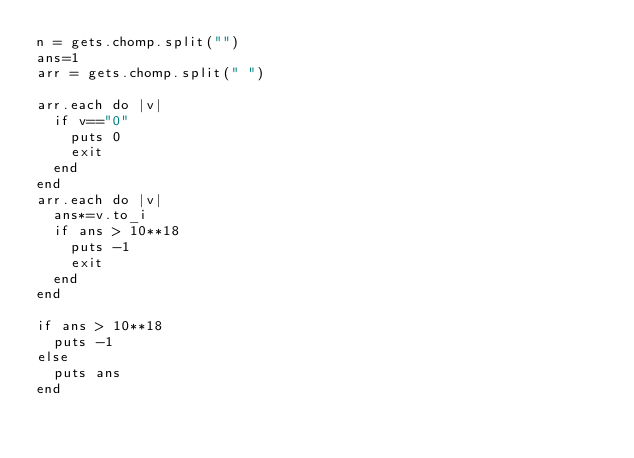Convert code to text. <code><loc_0><loc_0><loc_500><loc_500><_Ruby_>n = gets.chomp.split("")
ans=1
arr = gets.chomp.split(" ")

arr.each do |v|
  if v=="0"
    puts 0
    exit
  end
end
arr.each do |v|
  ans*=v.to_i
  if ans > 10**18
    puts -1
    exit
  end
end

if ans > 10**18
  puts -1
else
  puts ans
end</code> 